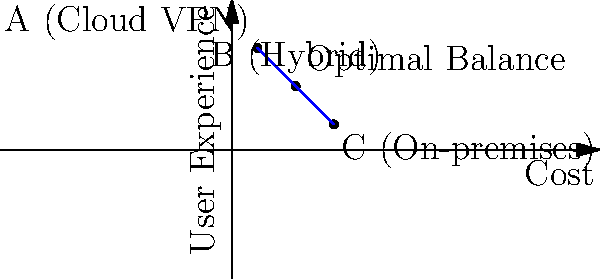Based on the graph showing the relationship between cost and user experience for different VPN setups, which option (A, B, or C) would you choose for your small business to balance cost-saving measures with providing a great user experience for remote workers? To answer this question, let's analyze the graph and consider the trade-offs between cost and user experience for each option:

1. Point A (Cloud VPN):
   - High user experience (0.8 on the y-axis)
   - Low cost (0.2 on the x-axis)
   - Pros: Easy to set up and manage, scalable, often includes built-in security features
   - Cons: May have limitations on customization, potential data privacy concerns

2. Point B (Hybrid):
   - Moderate user experience (0.5 on the y-axis)
   - Moderate cost (0.5 on the x-axis)
   - Pros: Balances the benefits of both cloud and on-premises solutions
   - Cons: May require more complex setup and management

3. Point C (On-premises):
   - Low user experience (0.2 on the y-axis)
   - High cost (0.8 on the x-axis)
   - Pros: Full control over infrastructure and data
   - Cons: Higher initial and maintenance costs, potentially more complex for remote users

Given the persona of "A fellow small business owner who believes in balancing cost-saving measures with providing a great user experience," the optimal choice would be option B (Hybrid).

Reasons for choosing B:
1. It offers a balanced approach between cost and user experience.
2. It allows for some cost savings compared to a fully on-premises solution.
3. It provides better user experience than a purely on-premises solution.
4. It offers more control and potential customization than a fully cloud-based solution.
5. It aligns with the "optimal balance" point indicated on the graph.

This choice reflects the small business owner's desire to balance cost-saving measures with a great user experience, without going to extremes in either direction.
Answer: B (Hybrid) 